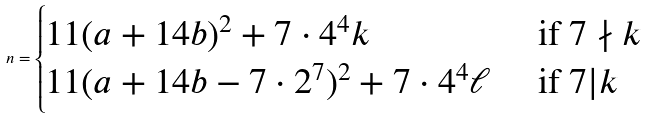<formula> <loc_0><loc_0><loc_500><loc_500>n = \begin{cases} 1 1 ( a + 1 4 b ) ^ { 2 } + 7 \cdot 4 ^ { 4 } k & \text { if } 7 \nmid k \\ 1 1 ( a + 1 4 b - 7 \cdot 2 ^ { 7 } ) ^ { 2 } + 7 \cdot 4 ^ { 4 } \ell & \text { if } 7 | k \end{cases}</formula> 